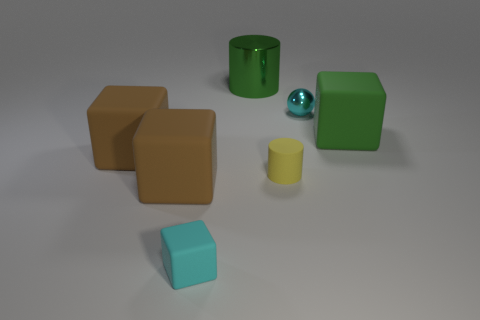There is a matte thing on the right side of the yellow cylinder; is it the same color as the big cylinder?
Provide a succinct answer. Yes. There is a green matte object that is the same shape as the cyan matte thing; what is its size?
Your answer should be very brief. Large. Is there anything else that is the same size as the cyan shiny object?
Ensure brevity in your answer.  Yes. What is the material of the cyan object that is on the right side of the cyan object to the left of the cylinder that is behind the large green rubber thing?
Offer a very short reply. Metal. Are there more large brown rubber cubes that are behind the cyan matte thing than yellow rubber cylinders that are on the left side of the yellow matte thing?
Ensure brevity in your answer.  Yes. Do the cyan metal ball and the cyan matte object have the same size?
Make the answer very short. Yes. The rubber object that is the same shape as the green metal thing is what color?
Offer a very short reply. Yellow. What number of tiny objects are the same color as the tiny sphere?
Your answer should be compact. 1. Are there more matte blocks behind the tiny cyan block than large cyan rubber objects?
Offer a very short reply. Yes. The thing to the right of the metal object that is in front of the large green cylinder is what color?
Make the answer very short. Green. 